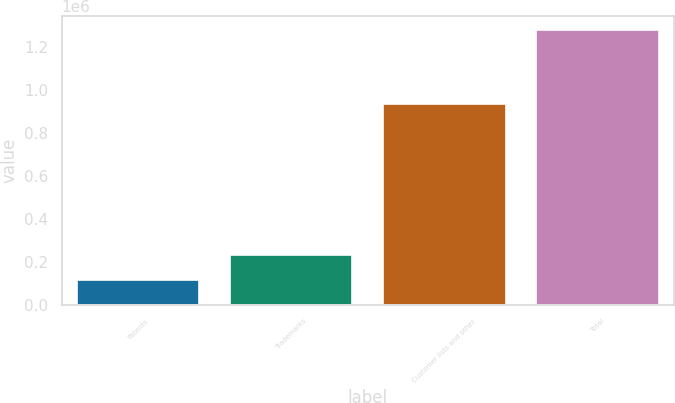<chart> <loc_0><loc_0><loc_500><loc_500><bar_chart><fcel>Patents<fcel>Trademarks<fcel>Customer lists and other<fcel>Total<nl><fcel>117440<fcel>233585<fcel>933867<fcel>1.27889e+06<nl></chart> 